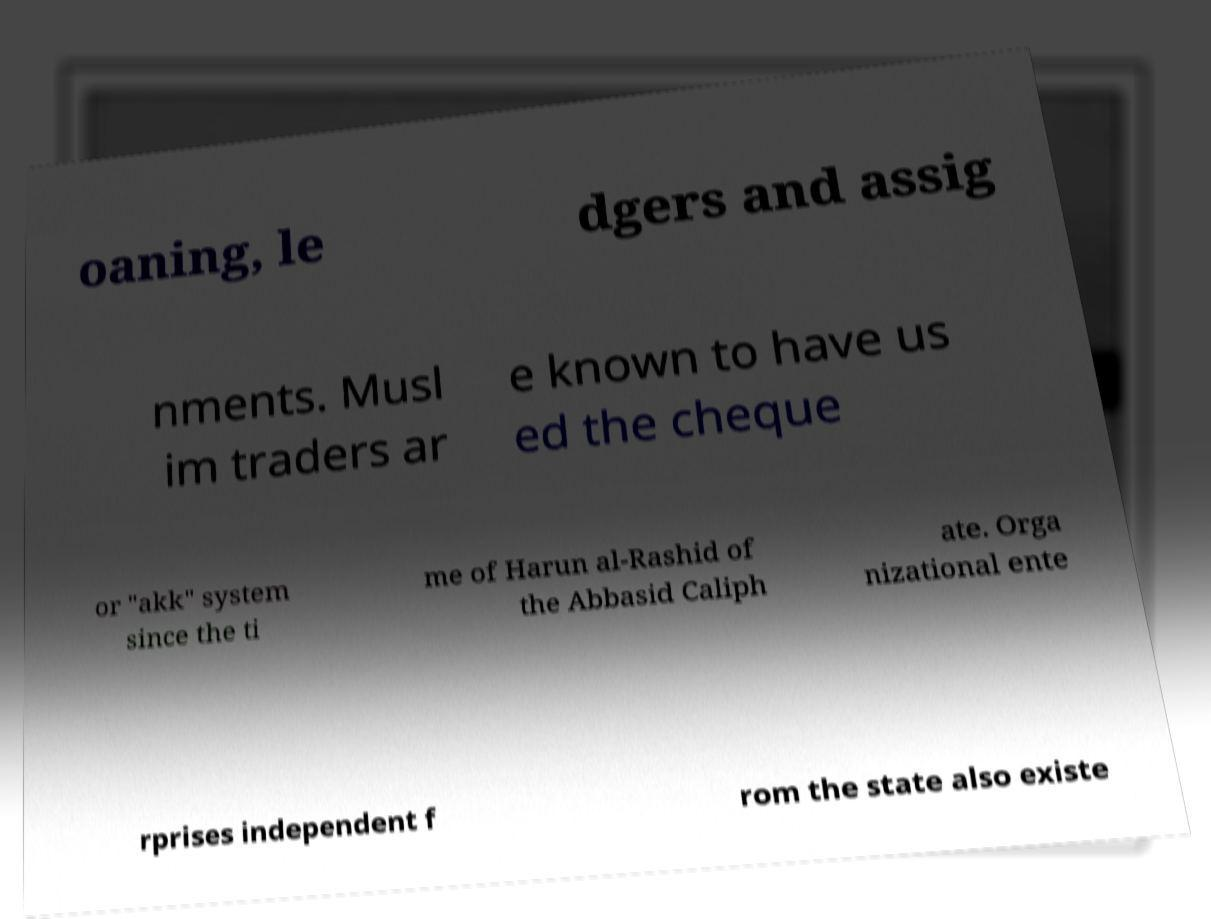There's text embedded in this image that I need extracted. Can you transcribe it verbatim? oaning, le dgers and assig nments. Musl im traders ar e known to have us ed the cheque or "akk" system since the ti me of Harun al-Rashid of the Abbasid Caliph ate. Orga nizational ente rprises independent f rom the state also existe 